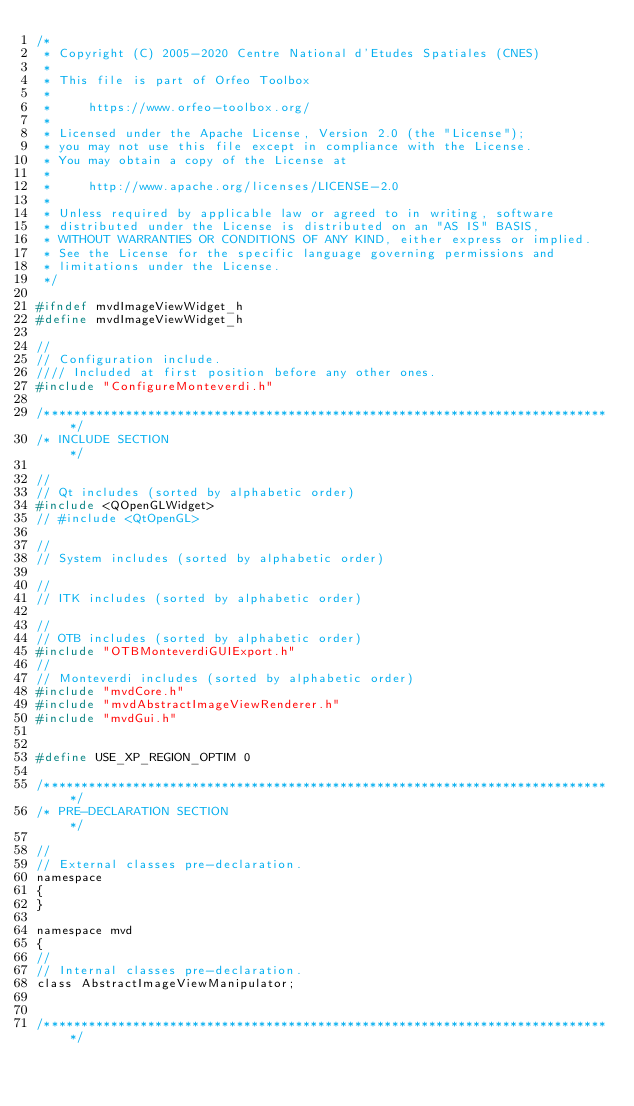<code> <loc_0><loc_0><loc_500><loc_500><_C_>/*
 * Copyright (C) 2005-2020 Centre National d'Etudes Spatiales (CNES)
 *
 * This file is part of Orfeo Toolbox
 *
 *     https://www.orfeo-toolbox.org/
 *
 * Licensed under the Apache License, Version 2.0 (the "License");
 * you may not use this file except in compliance with the License.
 * You may obtain a copy of the License at
 *
 *     http://www.apache.org/licenses/LICENSE-2.0
 *
 * Unless required by applicable law or agreed to in writing, software
 * distributed under the License is distributed on an "AS IS" BASIS,
 * WITHOUT WARRANTIES OR CONDITIONS OF ANY KIND, either express or implied.
 * See the License for the specific language governing permissions and
 * limitations under the License.
 */

#ifndef mvdImageViewWidget_h
#define mvdImageViewWidget_h

//
// Configuration include.
//// Included at first position before any other ones.
#include "ConfigureMonteverdi.h"

/*****************************************************************************/
/* INCLUDE SECTION                                                           */

//
// Qt includes (sorted by alphabetic order)
#include <QOpenGLWidget>
// #include <QtOpenGL>

//
// System includes (sorted by alphabetic order)

//
// ITK includes (sorted by alphabetic order)

//
// OTB includes (sorted by alphabetic order)
#include "OTBMonteverdiGUIExport.h"
//
// Monteverdi includes (sorted by alphabetic order)
#include "mvdCore.h"
#include "mvdAbstractImageViewRenderer.h"
#include "mvdGui.h"


#define USE_XP_REGION_OPTIM 0

/*****************************************************************************/
/* PRE-DECLARATION SECTION                                                   */

//
// External classes pre-declaration.
namespace
{
}

namespace mvd
{
//
// Internal classes pre-declaration.
class AbstractImageViewManipulator;


/*****************************************************************************/</code> 